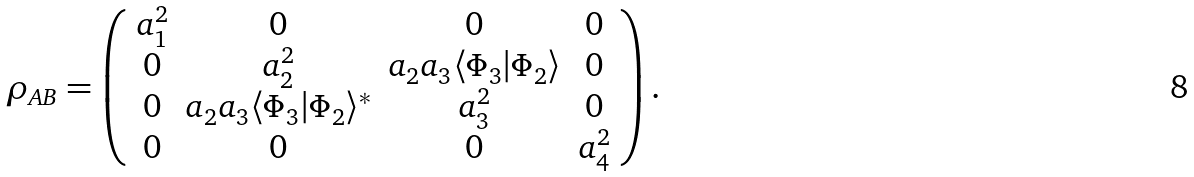<formula> <loc_0><loc_0><loc_500><loc_500>\rho _ { A B } = \left ( \begin{array} { c c c c } a _ { 1 } ^ { 2 } & 0 & 0 & 0 \\ 0 & a _ { 2 } ^ { 2 } & a _ { 2 } a _ { 3 } \langle \Phi _ { 3 } | \Phi _ { 2 } \rangle & 0 \\ 0 & a _ { 2 } a _ { 3 } \langle \Phi _ { 3 } | \Phi _ { 2 } \rangle ^ { * } & a _ { 3 } ^ { 2 } & 0 \\ 0 & 0 & 0 & a _ { 4 } ^ { 2 } \end{array} \right ) .</formula> 